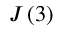Convert formula to latex. <formula><loc_0><loc_0><loc_500><loc_500>J \left ( 3 \right )</formula> 